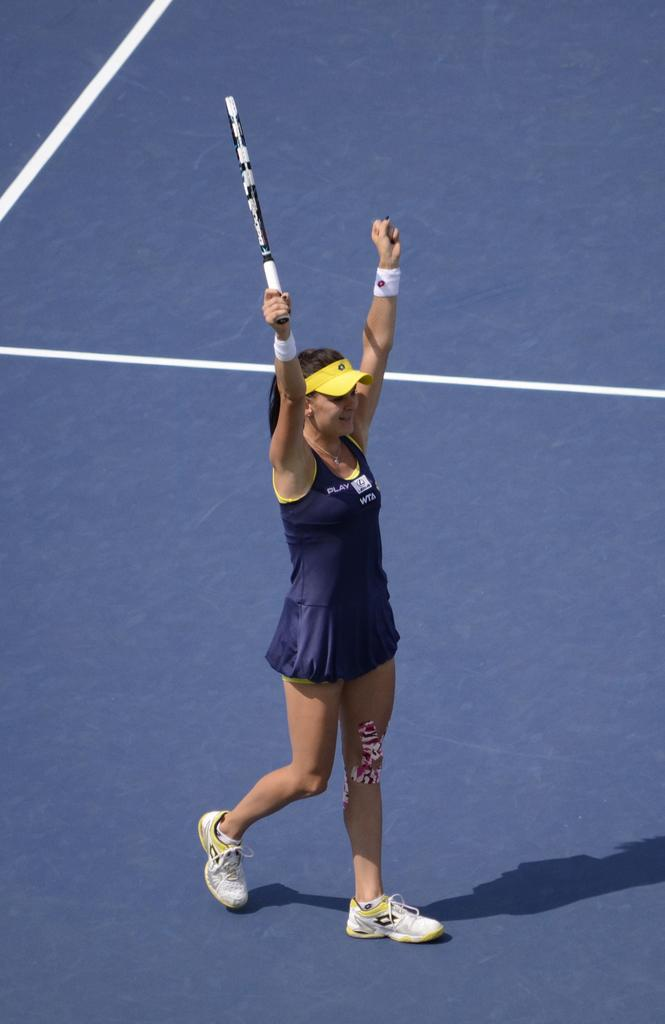What is the main subject of the image? The main subject of the image is a woman. What is the woman doing in the image? The woman is walking and raising her hands up in the image. What is the woman wearing on her head? The woman is wearing a yellow color cap in the image. What color is the dress the woman is wearing? The woman is wearing a blue color dress in the image. What type of footwear is the woman wearing? The woman is wearing shoes in the image. What object is the woman holding in her hand? The woman is holding a bat in her hand in the image. Can you see a giraffe walking down the alley in the image? There is no giraffe or alley present in the image; it features a woman walking and raising her hands up. 